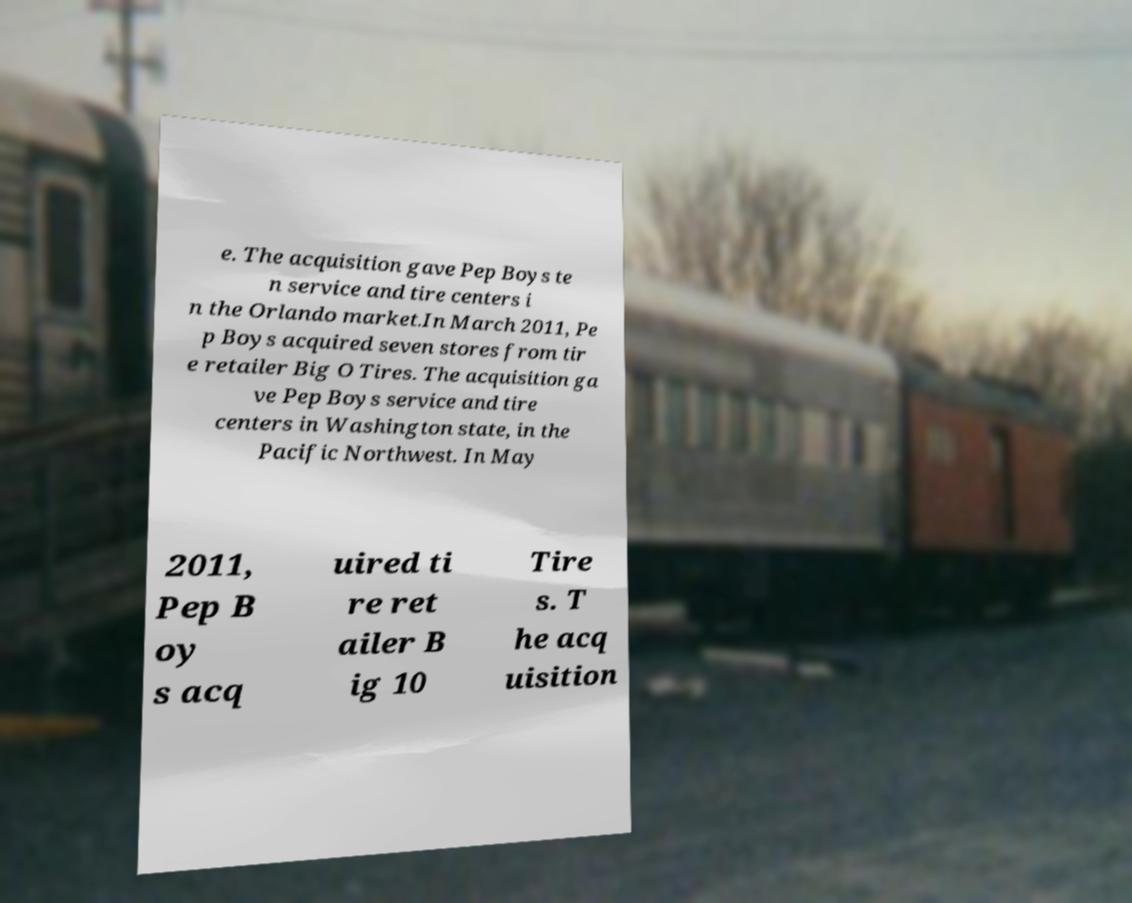I need the written content from this picture converted into text. Can you do that? e. The acquisition gave Pep Boys te n service and tire centers i n the Orlando market.In March 2011, Pe p Boys acquired seven stores from tir e retailer Big O Tires. The acquisition ga ve Pep Boys service and tire centers in Washington state, in the Pacific Northwest. In May 2011, Pep B oy s acq uired ti re ret ailer B ig 10 Tire s. T he acq uisition 